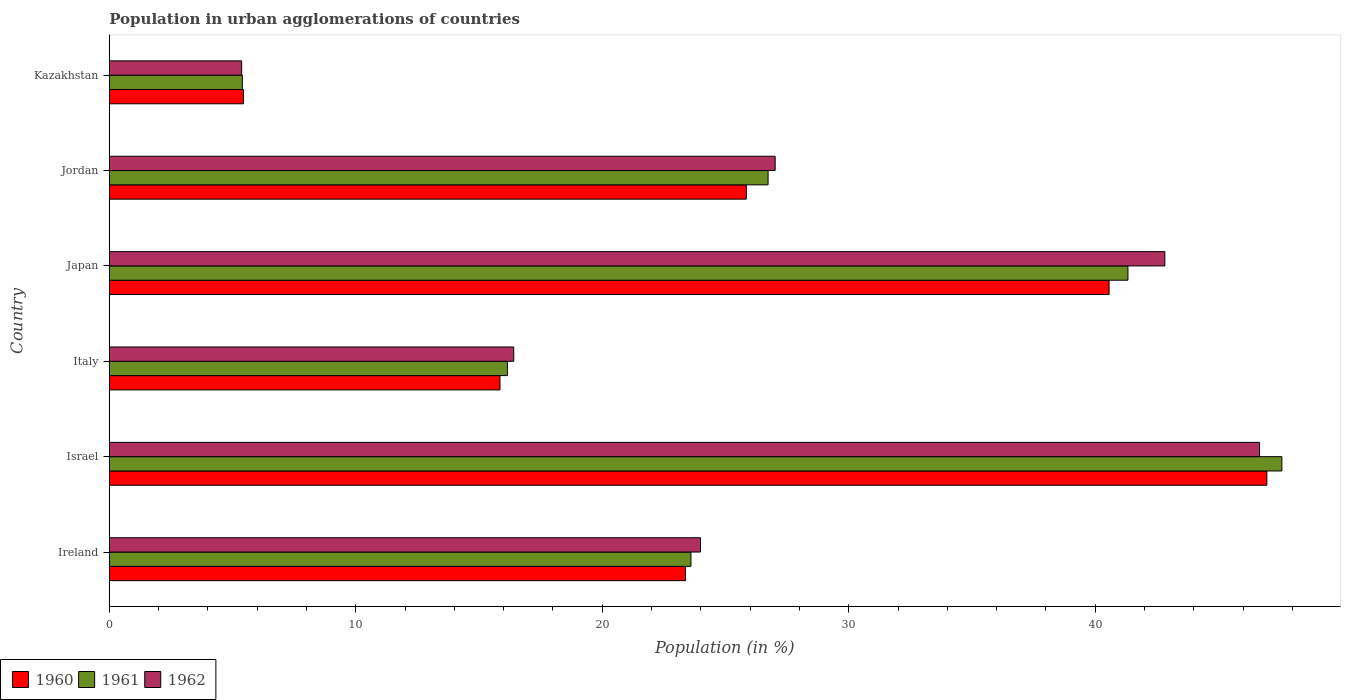How many groups of bars are there?
Provide a short and direct response. 6. Are the number of bars per tick equal to the number of legend labels?
Your response must be concise. Yes. How many bars are there on the 4th tick from the bottom?
Keep it short and to the point. 3. What is the label of the 1st group of bars from the top?
Ensure brevity in your answer.  Kazakhstan. What is the percentage of population in urban agglomerations in 1962 in Jordan?
Ensure brevity in your answer.  27.01. Across all countries, what is the maximum percentage of population in urban agglomerations in 1962?
Your response must be concise. 46.67. Across all countries, what is the minimum percentage of population in urban agglomerations in 1961?
Give a very brief answer. 5.4. In which country was the percentage of population in urban agglomerations in 1961 maximum?
Your response must be concise. Israel. In which country was the percentage of population in urban agglomerations in 1960 minimum?
Make the answer very short. Kazakhstan. What is the total percentage of population in urban agglomerations in 1961 in the graph?
Your response must be concise. 160.77. What is the difference between the percentage of population in urban agglomerations in 1961 in Israel and that in Japan?
Ensure brevity in your answer.  6.24. What is the difference between the percentage of population in urban agglomerations in 1962 in Ireland and the percentage of population in urban agglomerations in 1961 in Kazakhstan?
Your answer should be compact. 18.59. What is the average percentage of population in urban agglomerations in 1962 per country?
Your answer should be very brief. 27.04. What is the difference between the percentage of population in urban agglomerations in 1962 and percentage of population in urban agglomerations in 1961 in Israel?
Provide a succinct answer. -0.9. In how many countries, is the percentage of population in urban agglomerations in 1961 greater than 40 %?
Your answer should be compact. 2. What is the ratio of the percentage of population in urban agglomerations in 1961 in Japan to that in Kazakhstan?
Give a very brief answer. 7.66. Is the percentage of population in urban agglomerations in 1961 in Italy less than that in Kazakhstan?
Provide a short and direct response. No. What is the difference between the highest and the second highest percentage of population in urban agglomerations in 1961?
Keep it short and to the point. 6.24. What is the difference between the highest and the lowest percentage of population in urban agglomerations in 1962?
Make the answer very short. 41.29. What does the 3rd bar from the bottom in Kazakhstan represents?
Keep it short and to the point. 1962. How many bars are there?
Your response must be concise. 18. Are all the bars in the graph horizontal?
Offer a terse response. Yes. How many countries are there in the graph?
Your answer should be very brief. 6. What is the difference between two consecutive major ticks on the X-axis?
Give a very brief answer. 10. Where does the legend appear in the graph?
Keep it short and to the point. Bottom left. How are the legend labels stacked?
Your answer should be very brief. Horizontal. What is the title of the graph?
Keep it short and to the point. Population in urban agglomerations of countries. Does "1980" appear as one of the legend labels in the graph?
Make the answer very short. No. What is the label or title of the Y-axis?
Offer a very short reply. Country. What is the Population (in %) of 1960 in Ireland?
Make the answer very short. 23.38. What is the Population (in %) of 1961 in Ireland?
Ensure brevity in your answer.  23.6. What is the Population (in %) of 1962 in Ireland?
Your answer should be very brief. 23.98. What is the Population (in %) in 1960 in Israel?
Offer a very short reply. 46.96. What is the Population (in %) in 1961 in Israel?
Your response must be concise. 47.57. What is the Population (in %) in 1962 in Israel?
Your response must be concise. 46.67. What is the Population (in %) of 1960 in Italy?
Make the answer very short. 15.85. What is the Population (in %) in 1961 in Italy?
Offer a terse response. 16.15. What is the Population (in %) in 1962 in Italy?
Keep it short and to the point. 16.41. What is the Population (in %) in 1960 in Japan?
Ensure brevity in your answer.  40.56. What is the Population (in %) of 1961 in Japan?
Offer a very short reply. 41.33. What is the Population (in %) of 1962 in Japan?
Keep it short and to the point. 42.82. What is the Population (in %) of 1960 in Jordan?
Offer a terse response. 25.84. What is the Population (in %) in 1961 in Jordan?
Offer a very short reply. 26.73. What is the Population (in %) of 1962 in Jordan?
Your response must be concise. 27.01. What is the Population (in %) in 1960 in Kazakhstan?
Provide a succinct answer. 5.44. What is the Population (in %) in 1961 in Kazakhstan?
Your answer should be very brief. 5.4. What is the Population (in %) in 1962 in Kazakhstan?
Provide a succinct answer. 5.37. Across all countries, what is the maximum Population (in %) in 1960?
Make the answer very short. 46.96. Across all countries, what is the maximum Population (in %) of 1961?
Make the answer very short. 47.57. Across all countries, what is the maximum Population (in %) in 1962?
Provide a short and direct response. 46.67. Across all countries, what is the minimum Population (in %) in 1960?
Provide a short and direct response. 5.44. Across all countries, what is the minimum Population (in %) in 1961?
Offer a terse response. 5.4. Across all countries, what is the minimum Population (in %) in 1962?
Your answer should be very brief. 5.37. What is the total Population (in %) in 1960 in the graph?
Your response must be concise. 158.03. What is the total Population (in %) in 1961 in the graph?
Give a very brief answer. 160.77. What is the total Population (in %) of 1962 in the graph?
Offer a very short reply. 162.26. What is the difference between the Population (in %) of 1960 in Ireland and that in Israel?
Make the answer very short. -23.59. What is the difference between the Population (in %) in 1961 in Ireland and that in Israel?
Make the answer very short. -23.97. What is the difference between the Population (in %) in 1962 in Ireland and that in Israel?
Your response must be concise. -22.68. What is the difference between the Population (in %) in 1960 in Ireland and that in Italy?
Give a very brief answer. 7.53. What is the difference between the Population (in %) in 1961 in Ireland and that in Italy?
Provide a short and direct response. 7.45. What is the difference between the Population (in %) in 1962 in Ireland and that in Italy?
Give a very brief answer. 7.58. What is the difference between the Population (in %) in 1960 in Ireland and that in Japan?
Your response must be concise. -17.19. What is the difference between the Population (in %) of 1961 in Ireland and that in Japan?
Provide a succinct answer. -17.73. What is the difference between the Population (in %) in 1962 in Ireland and that in Japan?
Offer a terse response. -18.84. What is the difference between the Population (in %) of 1960 in Ireland and that in Jordan?
Provide a succinct answer. -2.47. What is the difference between the Population (in %) of 1961 in Ireland and that in Jordan?
Provide a short and direct response. -3.13. What is the difference between the Population (in %) in 1962 in Ireland and that in Jordan?
Keep it short and to the point. -3.03. What is the difference between the Population (in %) of 1960 in Ireland and that in Kazakhstan?
Offer a terse response. 17.93. What is the difference between the Population (in %) in 1961 in Ireland and that in Kazakhstan?
Offer a terse response. 18.2. What is the difference between the Population (in %) of 1962 in Ireland and that in Kazakhstan?
Make the answer very short. 18.61. What is the difference between the Population (in %) of 1960 in Israel and that in Italy?
Your answer should be very brief. 31.11. What is the difference between the Population (in %) in 1961 in Israel and that in Italy?
Your answer should be very brief. 31.42. What is the difference between the Population (in %) in 1962 in Israel and that in Italy?
Ensure brevity in your answer.  30.26. What is the difference between the Population (in %) of 1960 in Israel and that in Japan?
Provide a succinct answer. 6.4. What is the difference between the Population (in %) in 1961 in Israel and that in Japan?
Offer a terse response. 6.24. What is the difference between the Population (in %) of 1962 in Israel and that in Japan?
Keep it short and to the point. 3.84. What is the difference between the Population (in %) of 1960 in Israel and that in Jordan?
Provide a short and direct response. 21.12. What is the difference between the Population (in %) of 1961 in Israel and that in Jordan?
Offer a very short reply. 20.84. What is the difference between the Population (in %) in 1962 in Israel and that in Jordan?
Provide a short and direct response. 19.65. What is the difference between the Population (in %) of 1960 in Israel and that in Kazakhstan?
Your answer should be very brief. 41.52. What is the difference between the Population (in %) of 1961 in Israel and that in Kazakhstan?
Your response must be concise. 42.17. What is the difference between the Population (in %) of 1962 in Israel and that in Kazakhstan?
Make the answer very short. 41.29. What is the difference between the Population (in %) of 1960 in Italy and that in Japan?
Give a very brief answer. -24.71. What is the difference between the Population (in %) of 1961 in Italy and that in Japan?
Your response must be concise. -25.18. What is the difference between the Population (in %) in 1962 in Italy and that in Japan?
Ensure brevity in your answer.  -26.41. What is the difference between the Population (in %) of 1960 in Italy and that in Jordan?
Ensure brevity in your answer.  -9.99. What is the difference between the Population (in %) of 1961 in Italy and that in Jordan?
Offer a terse response. -10.58. What is the difference between the Population (in %) in 1962 in Italy and that in Jordan?
Your answer should be very brief. -10.61. What is the difference between the Population (in %) in 1960 in Italy and that in Kazakhstan?
Provide a short and direct response. 10.41. What is the difference between the Population (in %) in 1961 in Italy and that in Kazakhstan?
Give a very brief answer. 10.75. What is the difference between the Population (in %) of 1962 in Italy and that in Kazakhstan?
Provide a succinct answer. 11.04. What is the difference between the Population (in %) of 1960 in Japan and that in Jordan?
Ensure brevity in your answer.  14.72. What is the difference between the Population (in %) of 1961 in Japan and that in Jordan?
Provide a short and direct response. 14.6. What is the difference between the Population (in %) in 1962 in Japan and that in Jordan?
Your response must be concise. 15.81. What is the difference between the Population (in %) of 1960 in Japan and that in Kazakhstan?
Your response must be concise. 35.12. What is the difference between the Population (in %) in 1961 in Japan and that in Kazakhstan?
Make the answer very short. 35.93. What is the difference between the Population (in %) of 1962 in Japan and that in Kazakhstan?
Make the answer very short. 37.45. What is the difference between the Population (in %) of 1960 in Jordan and that in Kazakhstan?
Provide a succinct answer. 20.4. What is the difference between the Population (in %) in 1961 in Jordan and that in Kazakhstan?
Make the answer very short. 21.33. What is the difference between the Population (in %) in 1962 in Jordan and that in Kazakhstan?
Provide a short and direct response. 21.64. What is the difference between the Population (in %) of 1960 in Ireland and the Population (in %) of 1961 in Israel?
Give a very brief answer. -24.19. What is the difference between the Population (in %) of 1960 in Ireland and the Population (in %) of 1962 in Israel?
Your response must be concise. -23.29. What is the difference between the Population (in %) of 1961 in Ireland and the Population (in %) of 1962 in Israel?
Ensure brevity in your answer.  -23.07. What is the difference between the Population (in %) of 1960 in Ireland and the Population (in %) of 1961 in Italy?
Your response must be concise. 7.23. What is the difference between the Population (in %) of 1960 in Ireland and the Population (in %) of 1962 in Italy?
Your answer should be compact. 6.97. What is the difference between the Population (in %) in 1961 in Ireland and the Population (in %) in 1962 in Italy?
Give a very brief answer. 7.19. What is the difference between the Population (in %) in 1960 in Ireland and the Population (in %) in 1961 in Japan?
Give a very brief answer. -17.95. What is the difference between the Population (in %) of 1960 in Ireland and the Population (in %) of 1962 in Japan?
Ensure brevity in your answer.  -19.45. What is the difference between the Population (in %) of 1961 in Ireland and the Population (in %) of 1962 in Japan?
Your answer should be compact. -19.23. What is the difference between the Population (in %) in 1960 in Ireland and the Population (in %) in 1961 in Jordan?
Provide a short and direct response. -3.35. What is the difference between the Population (in %) of 1960 in Ireland and the Population (in %) of 1962 in Jordan?
Your answer should be compact. -3.64. What is the difference between the Population (in %) in 1961 in Ireland and the Population (in %) in 1962 in Jordan?
Keep it short and to the point. -3.42. What is the difference between the Population (in %) of 1960 in Ireland and the Population (in %) of 1961 in Kazakhstan?
Provide a short and direct response. 17.98. What is the difference between the Population (in %) of 1960 in Ireland and the Population (in %) of 1962 in Kazakhstan?
Your answer should be compact. 18.01. What is the difference between the Population (in %) of 1961 in Ireland and the Population (in %) of 1962 in Kazakhstan?
Ensure brevity in your answer.  18.23. What is the difference between the Population (in %) in 1960 in Israel and the Population (in %) in 1961 in Italy?
Your answer should be compact. 30.81. What is the difference between the Population (in %) in 1960 in Israel and the Population (in %) in 1962 in Italy?
Your answer should be compact. 30.55. What is the difference between the Population (in %) in 1961 in Israel and the Population (in %) in 1962 in Italy?
Your answer should be very brief. 31.16. What is the difference between the Population (in %) of 1960 in Israel and the Population (in %) of 1961 in Japan?
Offer a very short reply. 5.64. What is the difference between the Population (in %) in 1960 in Israel and the Population (in %) in 1962 in Japan?
Offer a very short reply. 4.14. What is the difference between the Population (in %) of 1961 in Israel and the Population (in %) of 1962 in Japan?
Offer a very short reply. 4.75. What is the difference between the Population (in %) of 1960 in Israel and the Population (in %) of 1961 in Jordan?
Your answer should be compact. 20.23. What is the difference between the Population (in %) of 1960 in Israel and the Population (in %) of 1962 in Jordan?
Make the answer very short. 19.95. What is the difference between the Population (in %) of 1961 in Israel and the Population (in %) of 1962 in Jordan?
Your answer should be very brief. 20.56. What is the difference between the Population (in %) in 1960 in Israel and the Population (in %) in 1961 in Kazakhstan?
Your answer should be compact. 41.56. What is the difference between the Population (in %) of 1960 in Israel and the Population (in %) of 1962 in Kazakhstan?
Your answer should be very brief. 41.59. What is the difference between the Population (in %) of 1961 in Israel and the Population (in %) of 1962 in Kazakhstan?
Keep it short and to the point. 42.2. What is the difference between the Population (in %) of 1960 in Italy and the Population (in %) of 1961 in Japan?
Offer a terse response. -25.48. What is the difference between the Population (in %) of 1960 in Italy and the Population (in %) of 1962 in Japan?
Ensure brevity in your answer.  -26.97. What is the difference between the Population (in %) of 1961 in Italy and the Population (in %) of 1962 in Japan?
Keep it short and to the point. -26.67. What is the difference between the Population (in %) in 1960 in Italy and the Population (in %) in 1961 in Jordan?
Your response must be concise. -10.88. What is the difference between the Population (in %) in 1960 in Italy and the Population (in %) in 1962 in Jordan?
Provide a succinct answer. -11.16. What is the difference between the Population (in %) of 1961 in Italy and the Population (in %) of 1962 in Jordan?
Ensure brevity in your answer.  -10.86. What is the difference between the Population (in %) in 1960 in Italy and the Population (in %) in 1961 in Kazakhstan?
Your response must be concise. 10.45. What is the difference between the Population (in %) of 1960 in Italy and the Population (in %) of 1962 in Kazakhstan?
Your answer should be compact. 10.48. What is the difference between the Population (in %) in 1961 in Italy and the Population (in %) in 1962 in Kazakhstan?
Give a very brief answer. 10.78. What is the difference between the Population (in %) of 1960 in Japan and the Population (in %) of 1961 in Jordan?
Give a very brief answer. 13.83. What is the difference between the Population (in %) of 1960 in Japan and the Population (in %) of 1962 in Jordan?
Keep it short and to the point. 13.55. What is the difference between the Population (in %) of 1961 in Japan and the Population (in %) of 1962 in Jordan?
Keep it short and to the point. 14.31. What is the difference between the Population (in %) in 1960 in Japan and the Population (in %) in 1961 in Kazakhstan?
Provide a succinct answer. 35.16. What is the difference between the Population (in %) in 1960 in Japan and the Population (in %) in 1962 in Kazakhstan?
Offer a very short reply. 35.19. What is the difference between the Population (in %) of 1961 in Japan and the Population (in %) of 1962 in Kazakhstan?
Ensure brevity in your answer.  35.95. What is the difference between the Population (in %) in 1960 in Jordan and the Population (in %) in 1961 in Kazakhstan?
Offer a very short reply. 20.44. What is the difference between the Population (in %) in 1960 in Jordan and the Population (in %) in 1962 in Kazakhstan?
Ensure brevity in your answer.  20.47. What is the difference between the Population (in %) in 1961 in Jordan and the Population (in %) in 1962 in Kazakhstan?
Your answer should be very brief. 21.36. What is the average Population (in %) of 1960 per country?
Your response must be concise. 26.34. What is the average Population (in %) in 1961 per country?
Provide a succinct answer. 26.79. What is the average Population (in %) in 1962 per country?
Your answer should be compact. 27.04. What is the difference between the Population (in %) of 1960 and Population (in %) of 1961 in Ireland?
Your answer should be compact. -0.22. What is the difference between the Population (in %) of 1960 and Population (in %) of 1962 in Ireland?
Offer a very short reply. -0.61. What is the difference between the Population (in %) of 1961 and Population (in %) of 1962 in Ireland?
Ensure brevity in your answer.  -0.39. What is the difference between the Population (in %) of 1960 and Population (in %) of 1961 in Israel?
Provide a succinct answer. -0.61. What is the difference between the Population (in %) in 1960 and Population (in %) in 1962 in Israel?
Give a very brief answer. 0.3. What is the difference between the Population (in %) of 1961 and Population (in %) of 1962 in Israel?
Make the answer very short. 0.9. What is the difference between the Population (in %) in 1960 and Population (in %) in 1961 in Italy?
Provide a short and direct response. -0.3. What is the difference between the Population (in %) of 1960 and Population (in %) of 1962 in Italy?
Your response must be concise. -0.56. What is the difference between the Population (in %) of 1961 and Population (in %) of 1962 in Italy?
Make the answer very short. -0.26. What is the difference between the Population (in %) in 1960 and Population (in %) in 1961 in Japan?
Give a very brief answer. -0.76. What is the difference between the Population (in %) in 1960 and Population (in %) in 1962 in Japan?
Keep it short and to the point. -2.26. What is the difference between the Population (in %) in 1961 and Population (in %) in 1962 in Japan?
Offer a very short reply. -1.5. What is the difference between the Population (in %) in 1960 and Population (in %) in 1961 in Jordan?
Offer a very short reply. -0.88. What is the difference between the Population (in %) in 1960 and Population (in %) in 1962 in Jordan?
Offer a terse response. -1.17. What is the difference between the Population (in %) of 1961 and Population (in %) of 1962 in Jordan?
Offer a very short reply. -0.29. What is the difference between the Population (in %) in 1960 and Population (in %) in 1961 in Kazakhstan?
Ensure brevity in your answer.  0.04. What is the difference between the Population (in %) in 1960 and Population (in %) in 1962 in Kazakhstan?
Offer a very short reply. 0.07. What is the difference between the Population (in %) of 1961 and Population (in %) of 1962 in Kazakhstan?
Keep it short and to the point. 0.03. What is the ratio of the Population (in %) in 1960 in Ireland to that in Israel?
Make the answer very short. 0.5. What is the ratio of the Population (in %) of 1961 in Ireland to that in Israel?
Your answer should be compact. 0.5. What is the ratio of the Population (in %) of 1962 in Ireland to that in Israel?
Offer a terse response. 0.51. What is the ratio of the Population (in %) in 1960 in Ireland to that in Italy?
Offer a very short reply. 1.47. What is the ratio of the Population (in %) in 1961 in Ireland to that in Italy?
Give a very brief answer. 1.46. What is the ratio of the Population (in %) in 1962 in Ireland to that in Italy?
Provide a succinct answer. 1.46. What is the ratio of the Population (in %) of 1960 in Ireland to that in Japan?
Give a very brief answer. 0.58. What is the ratio of the Population (in %) of 1961 in Ireland to that in Japan?
Your response must be concise. 0.57. What is the ratio of the Population (in %) of 1962 in Ireland to that in Japan?
Offer a terse response. 0.56. What is the ratio of the Population (in %) of 1960 in Ireland to that in Jordan?
Your answer should be very brief. 0.9. What is the ratio of the Population (in %) of 1961 in Ireland to that in Jordan?
Ensure brevity in your answer.  0.88. What is the ratio of the Population (in %) in 1962 in Ireland to that in Jordan?
Your response must be concise. 0.89. What is the ratio of the Population (in %) of 1960 in Ireland to that in Kazakhstan?
Ensure brevity in your answer.  4.3. What is the ratio of the Population (in %) in 1961 in Ireland to that in Kazakhstan?
Ensure brevity in your answer.  4.37. What is the ratio of the Population (in %) in 1962 in Ireland to that in Kazakhstan?
Ensure brevity in your answer.  4.47. What is the ratio of the Population (in %) in 1960 in Israel to that in Italy?
Ensure brevity in your answer.  2.96. What is the ratio of the Population (in %) in 1961 in Israel to that in Italy?
Ensure brevity in your answer.  2.95. What is the ratio of the Population (in %) of 1962 in Israel to that in Italy?
Your answer should be very brief. 2.84. What is the ratio of the Population (in %) in 1960 in Israel to that in Japan?
Provide a short and direct response. 1.16. What is the ratio of the Population (in %) of 1961 in Israel to that in Japan?
Keep it short and to the point. 1.15. What is the ratio of the Population (in %) of 1962 in Israel to that in Japan?
Make the answer very short. 1.09. What is the ratio of the Population (in %) in 1960 in Israel to that in Jordan?
Offer a very short reply. 1.82. What is the ratio of the Population (in %) of 1961 in Israel to that in Jordan?
Give a very brief answer. 1.78. What is the ratio of the Population (in %) of 1962 in Israel to that in Jordan?
Provide a succinct answer. 1.73. What is the ratio of the Population (in %) in 1960 in Israel to that in Kazakhstan?
Keep it short and to the point. 8.63. What is the ratio of the Population (in %) of 1961 in Israel to that in Kazakhstan?
Make the answer very short. 8.81. What is the ratio of the Population (in %) in 1962 in Israel to that in Kazakhstan?
Make the answer very short. 8.69. What is the ratio of the Population (in %) of 1960 in Italy to that in Japan?
Your answer should be very brief. 0.39. What is the ratio of the Population (in %) in 1961 in Italy to that in Japan?
Offer a very short reply. 0.39. What is the ratio of the Population (in %) of 1962 in Italy to that in Japan?
Make the answer very short. 0.38. What is the ratio of the Population (in %) in 1960 in Italy to that in Jordan?
Provide a succinct answer. 0.61. What is the ratio of the Population (in %) in 1961 in Italy to that in Jordan?
Your answer should be very brief. 0.6. What is the ratio of the Population (in %) of 1962 in Italy to that in Jordan?
Offer a very short reply. 0.61. What is the ratio of the Population (in %) in 1960 in Italy to that in Kazakhstan?
Your answer should be very brief. 2.91. What is the ratio of the Population (in %) in 1961 in Italy to that in Kazakhstan?
Keep it short and to the point. 2.99. What is the ratio of the Population (in %) of 1962 in Italy to that in Kazakhstan?
Keep it short and to the point. 3.06. What is the ratio of the Population (in %) in 1960 in Japan to that in Jordan?
Make the answer very short. 1.57. What is the ratio of the Population (in %) of 1961 in Japan to that in Jordan?
Your answer should be compact. 1.55. What is the ratio of the Population (in %) of 1962 in Japan to that in Jordan?
Your answer should be very brief. 1.59. What is the ratio of the Population (in %) of 1960 in Japan to that in Kazakhstan?
Make the answer very short. 7.45. What is the ratio of the Population (in %) in 1961 in Japan to that in Kazakhstan?
Give a very brief answer. 7.66. What is the ratio of the Population (in %) in 1962 in Japan to that in Kazakhstan?
Ensure brevity in your answer.  7.97. What is the ratio of the Population (in %) of 1960 in Jordan to that in Kazakhstan?
Keep it short and to the point. 4.75. What is the ratio of the Population (in %) in 1961 in Jordan to that in Kazakhstan?
Give a very brief answer. 4.95. What is the ratio of the Population (in %) in 1962 in Jordan to that in Kazakhstan?
Give a very brief answer. 5.03. What is the difference between the highest and the second highest Population (in %) in 1960?
Offer a very short reply. 6.4. What is the difference between the highest and the second highest Population (in %) of 1961?
Provide a short and direct response. 6.24. What is the difference between the highest and the second highest Population (in %) in 1962?
Offer a very short reply. 3.84. What is the difference between the highest and the lowest Population (in %) of 1960?
Offer a very short reply. 41.52. What is the difference between the highest and the lowest Population (in %) of 1961?
Ensure brevity in your answer.  42.17. What is the difference between the highest and the lowest Population (in %) of 1962?
Your answer should be very brief. 41.29. 